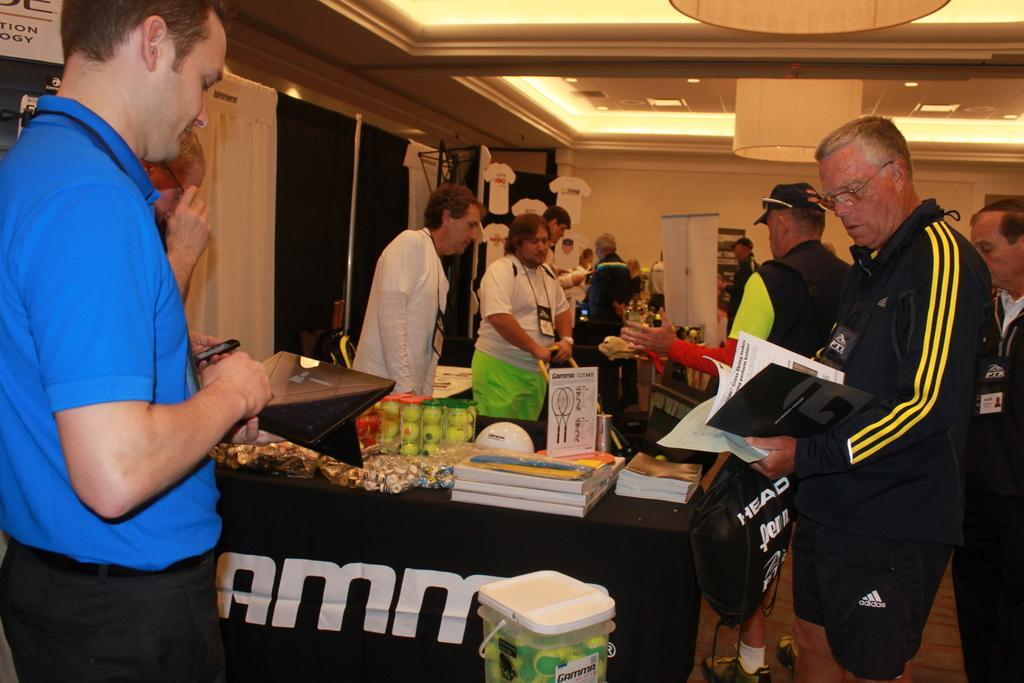Who or what can be seen in the image? There are people in the image. What are the people doing in the image? The people are standing in front of a table. What can be found on the table in the image? There are objects on the table. What type of soap is being used by the writer in the image? There is no writer or soap present in the image. What color is the coat worn by the person in the image? There is no coat visible in the image. 